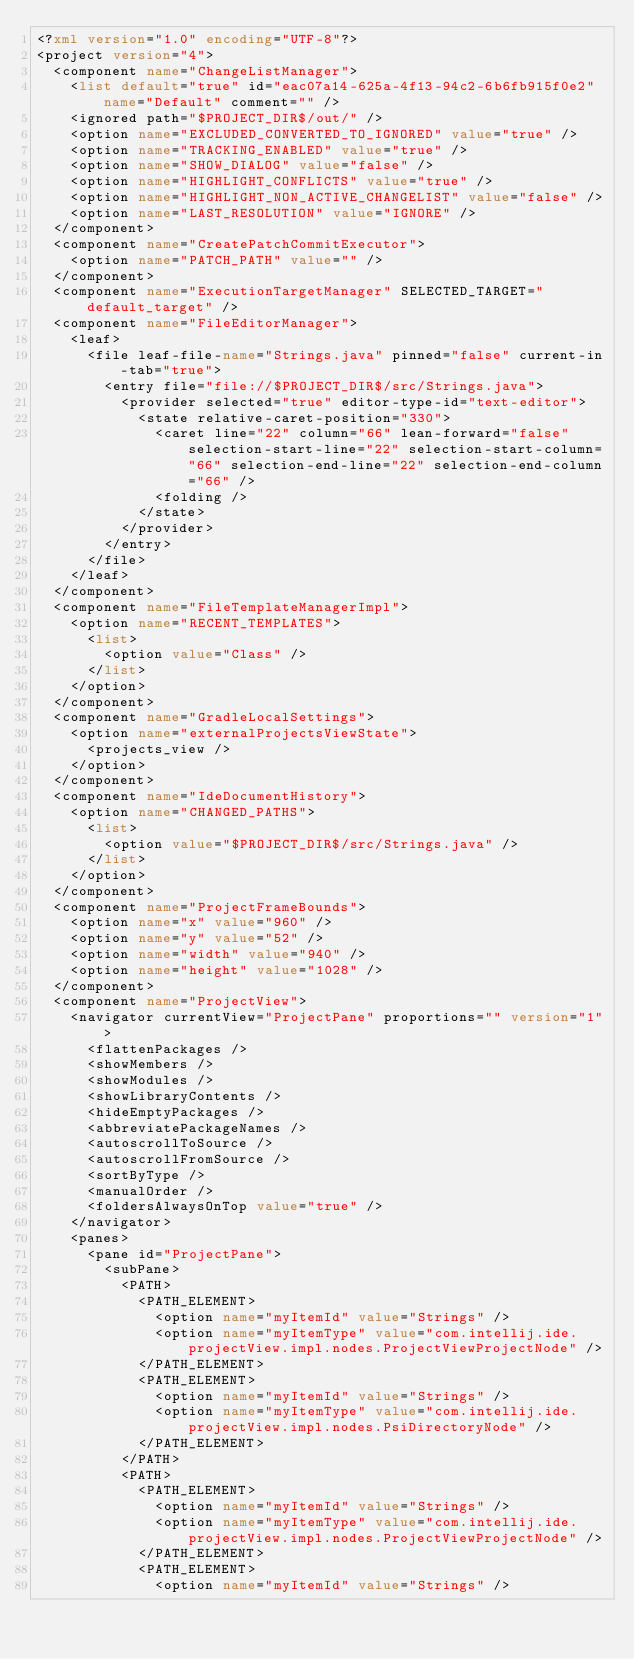Convert code to text. <code><loc_0><loc_0><loc_500><loc_500><_XML_><?xml version="1.0" encoding="UTF-8"?>
<project version="4">
  <component name="ChangeListManager">
    <list default="true" id="eac07a14-625a-4f13-94c2-6b6fb915f0e2" name="Default" comment="" />
    <ignored path="$PROJECT_DIR$/out/" />
    <option name="EXCLUDED_CONVERTED_TO_IGNORED" value="true" />
    <option name="TRACKING_ENABLED" value="true" />
    <option name="SHOW_DIALOG" value="false" />
    <option name="HIGHLIGHT_CONFLICTS" value="true" />
    <option name="HIGHLIGHT_NON_ACTIVE_CHANGELIST" value="false" />
    <option name="LAST_RESOLUTION" value="IGNORE" />
  </component>
  <component name="CreatePatchCommitExecutor">
    <option name="PATCH_PATH" value="" />
  </component>
  <component name="ExecutionTargetManager" SELECTED_TARGET="default_target" />
  <component name="FileEditorManager">
    <leaf>
      <file leaf-file-name="Strings.java" pinned="false" current-in-tab="true">
        <entry file="file://$PROJECT_DIR$/src/Strings.java">
          <provider selected="true" editor-type-id="text-editor">
            <state relative-caret-position="330">
              <caret line="22" column="66" lean-forward="false" selection-start-line="22" selection-start-column="66" selection-end-line="22" selection-end-column="66" />
              <folding />
            </state>
          </provider>
        </entry>
      </file>
    </leaf>
  </component>
  <component name="FileTemplateManagerImpl">
    <option name="RECENT_TEMPLATES">
      <list>
        <option value="Class" />
      </list>
    </option>
  </component>
  <component name="GradleLocalSettings">
    <option name="externalProjectsViewState">
      <projects_view />
    </option>
  </component>
  <component name="IdeDocumentHistory">
    <option name="CHANGED_PATHS">
      <list>
        <option value="$PROJECT_DIR$/src/Strings.java" />
      </list>
    </option>
  </component>
  <component name="ProjectFrameBounds">
    <option name="x" value="960" />
    <option name="y" value="52" />
    <option name="width" value="940" />
    <option name="height" value="1028" />
  </component>
  <component name="ProjectView">
    <navigator currentView="ProjectPane" proportions="" version="1">
      <flattenPackages />
      <showMembers />
      <showModules />
      <showLibraryContents />
      <hideEmptyPackages />
      <abbreviatePackageNames />
      <autoscrollToSource />
      <autoscrollFromSource />
      <sortByType />
      <manualOrder />
      <foldersAlwaysOnTop value="true" />
    </navigator>
    <panes>
      <pane id="ProjectPane">
        <subPane>
          <PATH>
            <PATH_ELEMENT>
              <option name="myItemId" value="Strings" />
              <option name="myItemType" value="com.intellij.ide.projectView.impl.nodes.ProjectViewProjectNode" />
            </PATH_ELEMENT>
            <PATH_ELEMENT>
              <option name="myItemId" value="Strings" />
              <option name="myItemType" value="com.intellij.ide.projectView.impl.nodes.PsiDirectoryNode" />
            </PATH_ELEMENT>
          </PATH>
          <PATH>
            <PATH_ELEMENT>
              <option name="myItemId" value="Strings" />
              <option name="myItemType" value="com.intellij.ide.projectView.impl.nodes.ProjectViewProjectNode" />
            </PATH_ELEMENT>
            <PATH_ELEMENT>
              <option name="myItemId" value="Strings" /></code> 